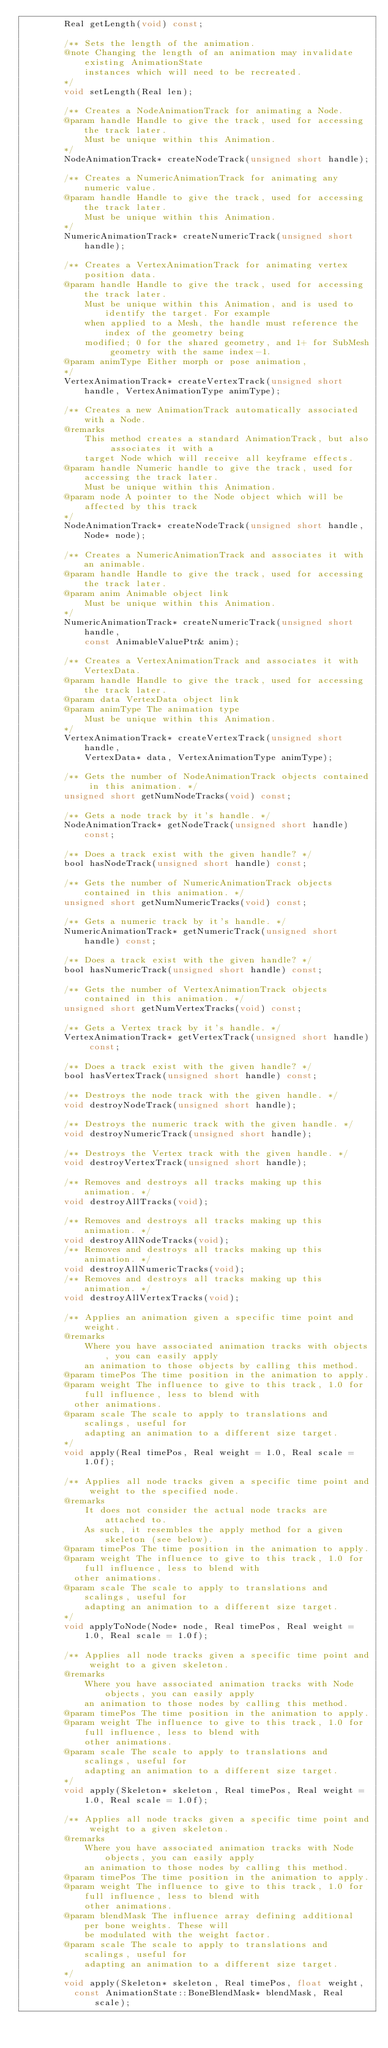Convert code to text. <code><loc_0><loc_0><loc_500><loc_500><_C_>        Real getLength(void) const;

        /** Sets the length of the animation. 
        @note Changing the length of an animation may invalidate existing AnimationState
            instances which will need to be recreated. 
        */
        void setLength(Real len);

        /** Creates a NodeAnimationTrack for animating a Node.
        @param handle Handle to give the track, used for accessing the track later. 
            Must be unique within this Animation.
        */
        NodeAnimationTrack* createNodeTrack(unsigned short handle);

        /** Creates a NumericAnimationTrack for animating any numeric value.
        @param handle Handle to give the track, used for accessing the track later. 
            Must be unique within this Animation.
        */
        NumericAnimationTrack* createNumericTrack(unsigned short handle);

        /** Creates a VertexAnimationTrack for animating vertex position data.
        @param handle Handle to give the track, used for accessing the track later. 
            Must be unique within this Animation, and is used to identify the target. For example
            when applied to a Mesh, the handle must reference the index of the geometry being 
            modified; 0 for the shared geometry, and 1+ for SubMesh geometry with the same index-1.
        @param animType Either morph or pose animation, 
        */
        VertexAnimationTrack* createVertexTrack(unsigned short handle, VertexAnimationType animType);

        /** Creates a new AnimationTrack automatically associated with a Node. 
        @remarks
            This method creates a standard AnimationTrack, but also associates it with a
            target Node which will receive all keyframe effects.
        @param handle Numeric handle to give the track, used for accessing the track later. 
            Must be unique within this Animation.
        @param node A pointer to the Node object which will be affected by this track
        */
        NodeAnimationTrack* createNodeTrack(unsigned short handle, Node* node);

        /** Creates a NumericAnimationTrack and associates it with an animable. 
        @param handle Handle to give the track, used for accessing the track later. 
        @param anim Animable object link
            Must be unique within this Animation.
        */
        NumericAnimationTrack* createNumericTrack(unsigned short handle, 
            const AnimableValuePtr& anim);

        /** Creates a VertexAnimationTrack and associates it with VertexData. 
        @param handle Handle to give the track, used for accessing the track later. 
        @param data VertexData object link
        @param animType The animation type 
            Must be unique within this Animation.
        */
        VertexAnimationTrack* createVertexTrack(unsigned short handle, 
            VertexData* data, VertexAnimationType animType);

        /** Gets the number of NodeAnimationTrack objects contained in this animation. */
        unsigned short getNumNodeTracks(void) const;

        /** Gets a node track by it's handle. */
        NodeAnimationTrack* getNodeTrack(unsigned short handle) const;

        /** Does a track exist with the given handle? */
        bool hasNodeTrack(unsigned short handle) const;

        /** Gets the number of NumericAnimationTrack objects contained in this animation. */
        unsigned short getNumNumericTracks(void) const;

        /** Gets a numeric track by it's handle. */
        NumericAnimationTrack* getNumericTrack(unsigned short handle) const;

        /** Does a track exist with the given handle? */
        bool hasNumericTrack(unsigned short handle) const;

        /** Gets the number of VertexAnimationTrack objects contained in this animation. */
        unsigned short getNumVertexTracks(void) const;

        /** Gets a Vertex track by it's handle. */
        VertexAnimationTrack* getVertexTrack(unsigned short handle) const;

        /** Does a track exist with the given handle? */
        bool hasVertexTrack(unsigned short handle) const;
        
        /** Destroys the node track with the given handle. */
        void destroyNodeTrack(unsigned short handle);

        /** Destroys the numeric track with the given handle. */
        void destroyNumericTrack(unsigned short handle);

        /** Destroys the Vertex track with the given handle. */
        void destroyVertexTrack(unsigned short handle);

        /** Removes and destroys all tracks making up this animation. */
        void destroyAllTracks(void);

        /** Removes and destroys all tracks making up this animation. */
        void destroyAllNodeTracks(void);
        /** Removes and destroys all tracks making up this animation. */
        void destroyAllNumericTracks(void);
        /** Removes and destroys all tracks making up this animation. */
        void destroyAllVertexTracks(void);

        /** Applies an animation given a specific time point and weight.
        @remarks
            Where you have associated animation tracks with objects, you can easily apply
            an animation to those objects by calling this method.
        @param timePos The time position in the animation to apply.
        @param weight The influence to give to this track, 1.0 for full influence, less to blend with
          other animations.
        @param scale The scale to apply to translations and scalings, useful for 
            adapting an animation to a different size target.
        */
        void apply(Real timePos, Real weight = 1.0, Real scale = 1.0f);

        /** Applies all node tracks given a specific time point and weight to the specified node.
        @remarks
            It does not consider the actual node tracks are attached to.
            As such, it resembles the apply method for a given skeleton (see below).
        @param timePos The time position in the animation to apply.
        @param weight The influence to give to this track, 1.0 for full influence, less to blend with
          other animations.
        @param scale The scale to apply to translations and scalings, useful for 
            adapting an animation to a different size target.
        */
        void applyToNode(Node* node, Real timePos, Real weight = 1.0, Real scale = 1.0f);

        /** Applies all node tracks given a specific time point and weight to a given skeleton.
        @remarks
            Where you have associated animation tracks with Node objects, you can easily apply
            an animation to those nodes by calling this method.
        @param timePos The time position in the animation to apply.
        @param weight The influence to give to this track, 1.0 for full influence, less to blend with
            other animations.
        @param scale The scale to apply to translations and scalings, useful for 
            adapting an animation to a different size target.
        */
        void apply(Skeleton* skeleton, Real timePos, Real weight = 1.0, Real scale = 1.0f);

        /** Applies all node tracks given a specific time point and weight to a given skeleton.
        @remarks
            Where you have associated animation tracks with Node objects, you can easily apply
            an animation to those nodes by calling this method.
        @param timePos The time position in the animation to apply.
        @param weight The influence to give to this track, 1.0 for full influence, less to blend with
            other animations.
        @param blendMask The influence array defining additional per bone weights. These will
            be modulated with the weight factor.
        @param scale The scale to apply to translations and scalings, useful for 
            adapting an animation to a different size target.
        */
        void apply(Skeleton* skeleton, Real timePos, float weight,
          const AnimationState::BoneBlendMask* blendMask, Real scale);
</code> 